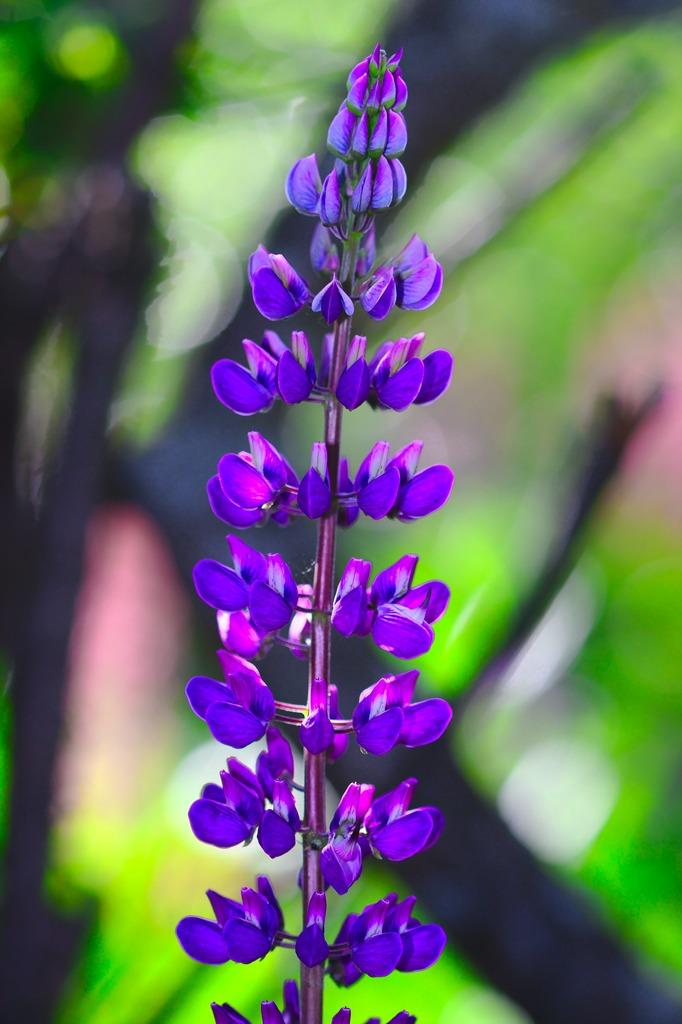What color are the flowers in the image? The flowers in the image are violet. What type of plant do the flowers belong to? The flowers belong to a plant. How would you describe the background of the image? The background of the image is blurred. What color is the background? The background color is green. What type of substance is being produced by the flowers in the image? There is no indication in the image that the flowers are producing any substance. 